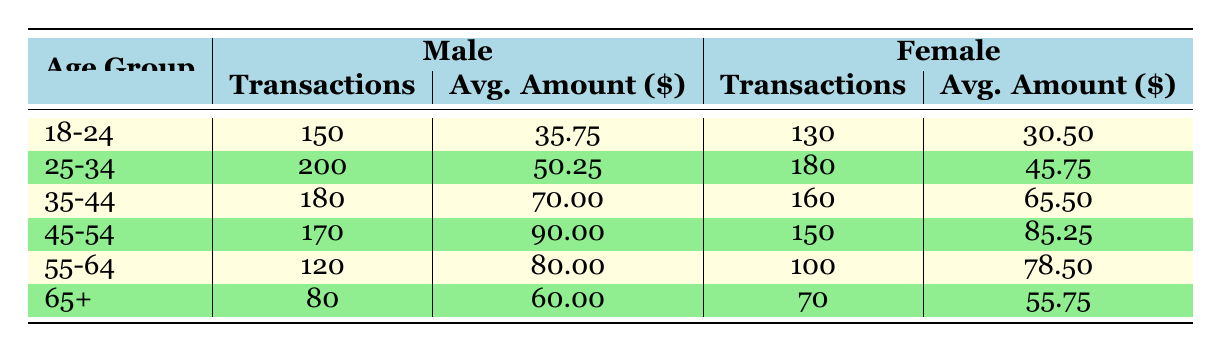What is the total number of daily transactions for males aged 25-34? According to the table, the number of daily transactions for males in the 25-34 age group is 200.
Answer: 200 What is the average transaction amount for females in the 45-54 age group? The table indicates that the average transaction amount for females in the 45-54 age group is 85.25.
Answer: 85.25 How many more transactions do males in the 35-44 age group have compared to females in the same age group? Males in the 35-44 age group have 180 transactions, while females have 160. The difference is 180 - 160 = 20.
Answer: 20 Is the average transaction amount for males in the 55-64 age group less than 75? The average transaction amount for males in the 55-64 age group is 80, which is not less than 75. Therefore, the statement is false.
Answer: No What is the total number of daily transactions for all age groups combined? To find the total number of transactions, I sum the transactions across all age groups: 150 + 130 + 200 + 180 + 180 + 160 + 170 + 150 + 120 + 100 + 80 + 70 = 1610.
Answer: 1610 How does the average transaction amount of males in the 45-54 age group compare to that of females in the same group? The average for males is 90.00 while females have 85.25. Thus, males have a higher average amount: 90.00 - 85.25 = 4.75 more.
Answer: Males have 4.75 more What is the total number of daily transactions for females aged 18-24 and 25-34 combined? For females in the 18-24 age group, there are 130 transactions and for 25-34 age group, there are 180 transactions. Summing these gives: 130 + 180 = 310 transactions.
Answer: 310 Are there more transactions for males in the 65+ age group compared to females in the same group? Males have 80 transactions while females have 70 transactions. Since 80 is greater than 70, the answer is true.
Answer: Yes What is the average of the average transaction amounts for all age groups combined for males? The average amounts for males across age groups are: 35.75, 50.25, 70.00, 90.00, 80.00, and 60.00. Summing these gives 386.00. Dividing by 6, the average is approximately 64.33.
Answer: 64.33 